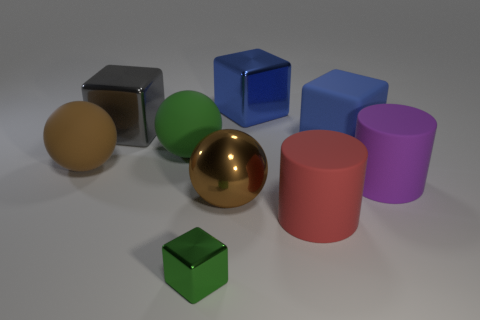Do the brown object that is to the right of the big green matte thing and the large blue matte thing have the same shape? No, they do not have the same shape. The brown object to the right of the big green item is a cube, while the large blue item is a different shape entirely, it appears to be a cuboid. Their general structure is three-dimensional with straight edges and flat faces, but their proportions are different, as a cube has equal dimensions on all sides and a cuboid has rectangular faces with varying lengths. 